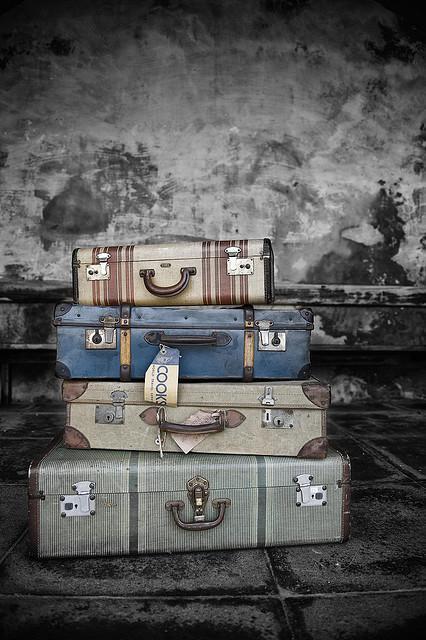How many suitcases are there?
Give a very brief answer. 4. How many people are shown?
Give a very brief answer. 0. How many suitcases have vertical stripes running down them?
Give a very brief answer. 3. How many suitcases are visible?
Give a very brief answer. 4. How many people are sitting down?
Give a very brief answer. 0. 